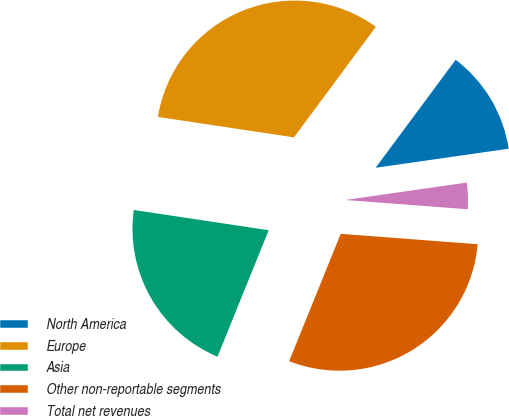<chart> <loc_0><loc_0><loc_500><loc_500><pie_chart><fcel>North America<fcel>Europe<fcel>Asia<fcel>Other non-reportable segments<fcel>Total net revenues<nl><fcel>12.58%<fcel>32.78%<fcel>21.25%<fcel>29.92%<fcel>3.47%<nl></chart> 